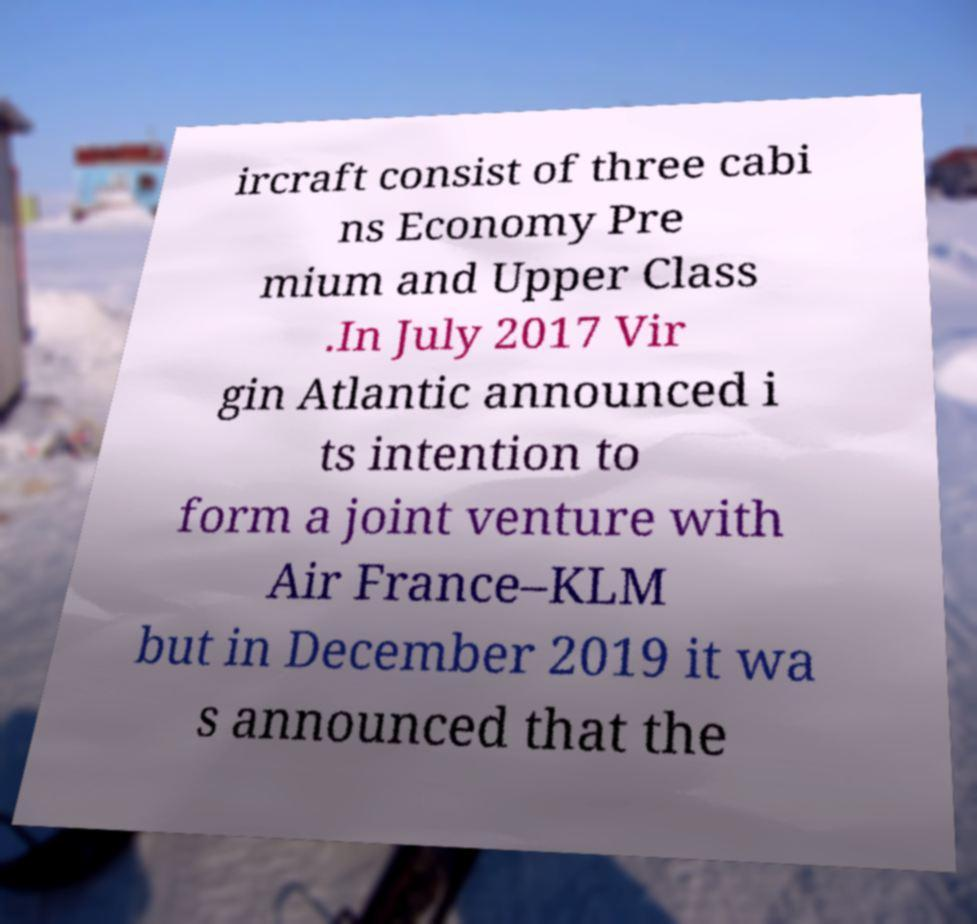Please read and relay the text visible in this image. What does it say? ircraft consist of three cabi ns Economy Pre mium and Upper Class .In July 2017 Vir gin Atlantic announced i ts intention to form a joint venture with Air France–KLM but in December 2019 it wa s announced that the 